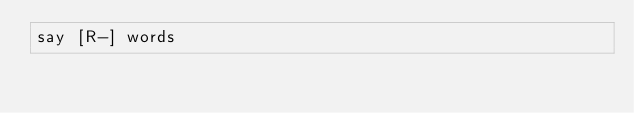Convert code to text. <code><loc_0><loc_0><loc_500><loc_500><_Perl_>say [R-] words</code> 